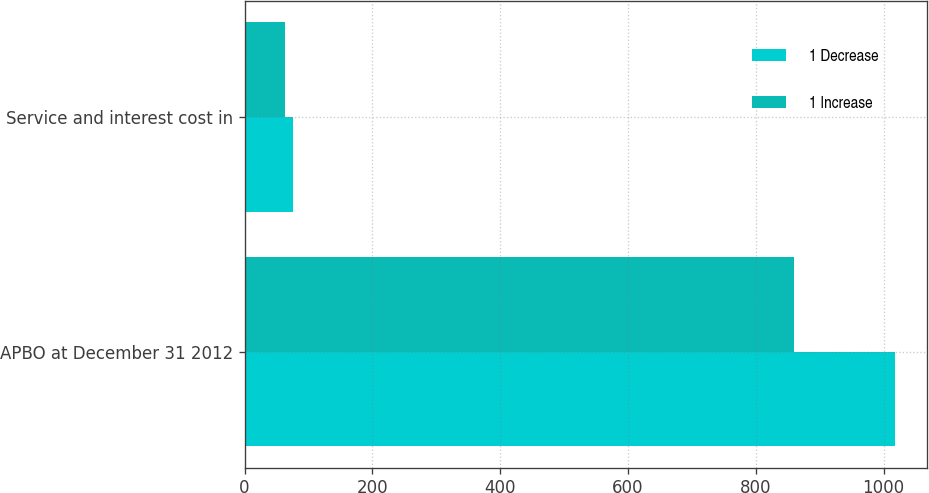<chart> <loc_0><loc_0><loc_500><loc_500><stacked_bar_chart><ecel><fcel>APBO at December 31 2012<fcel>Service and interest cost in<nl><fcel>1 Decrease<fcel>1017<fcel>76<nl><fcel>1 Increase<fcel>860<fcel>63<nl></chart> 